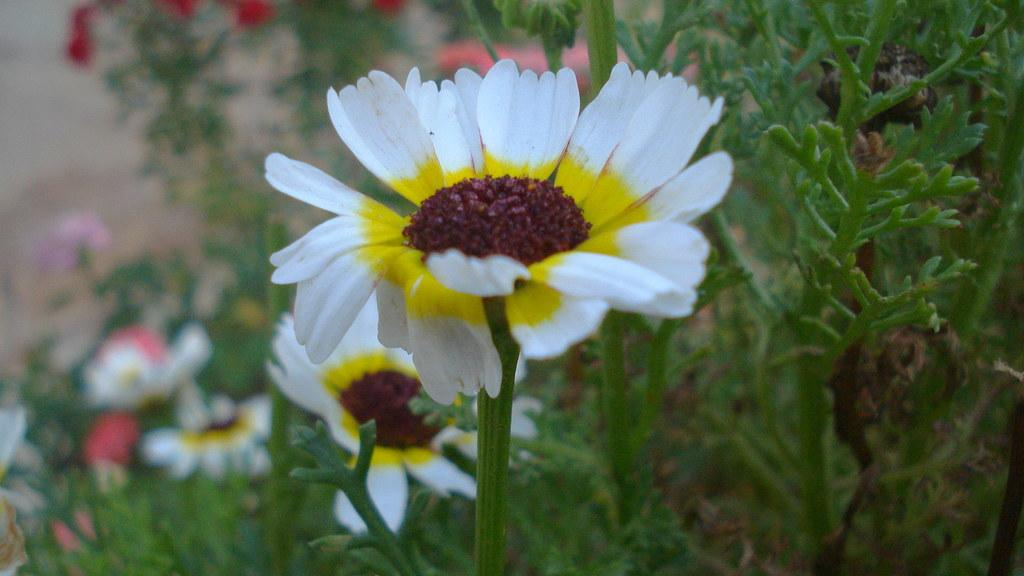What is the main subject in the foreground of the picture? There is a flower in the foreground of the picture. What can be seen in the background of the picture? There are flowers and plants in the background of the picture. How many trucks are parked near the flowers in the image? There are no trucks present in the image; it features flowers and plants. What type of birds can be seen flying over the flowers in the image? There are no birds visible in the image; it only shows flowers and plants. 